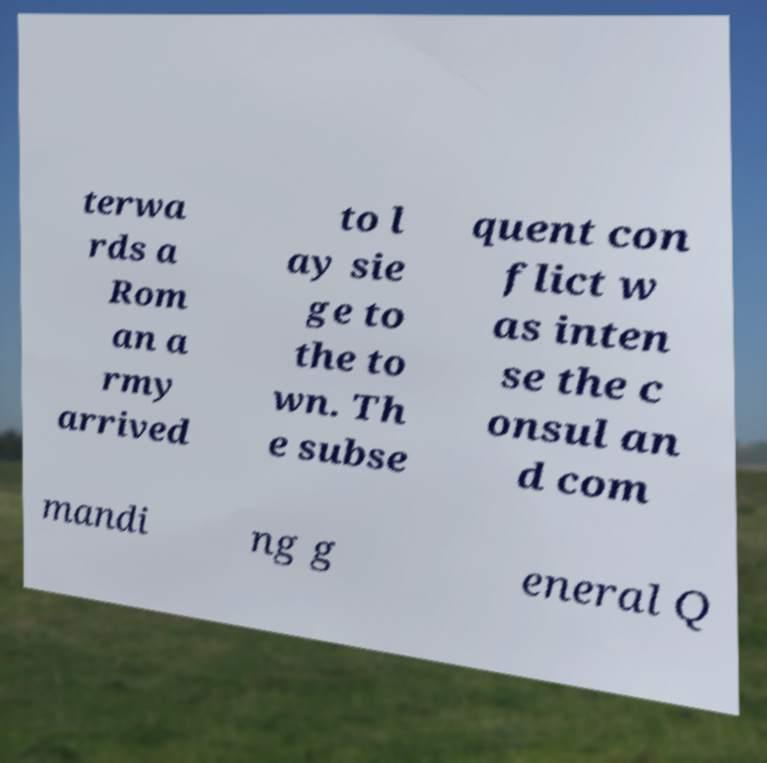Please read and relay the text visible in this image. What does it say? terwa rds a Rom an a rmy arrived to l ay sie ge to the to wn. Th e subse quent con flict w as inten se the c onsul an d com mandi ng g eneral Q 